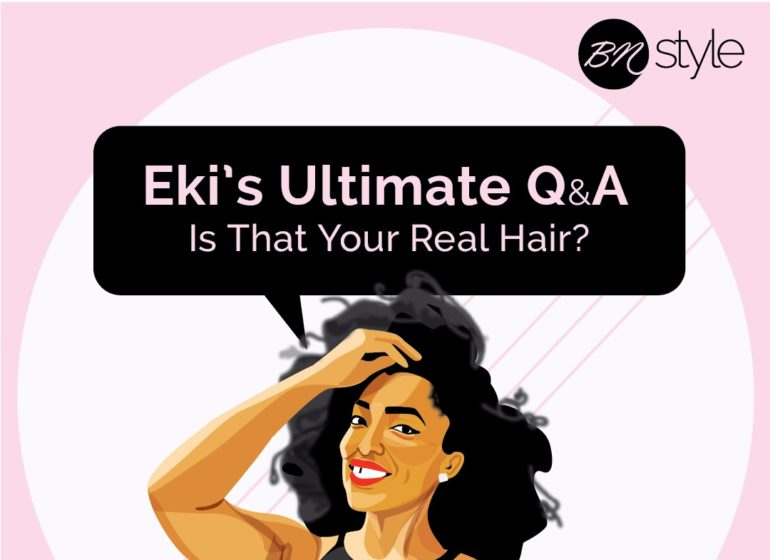Describe what the woman might talk about during a typical Q&A session. During a typical Q&A session, the woman might address common questions about natural hair, such as the best methods to transition from relaxed to natural hair and how to identify one's curl pattern. She could provide insights on avoiding breakage by detailing protective styling techniques like braids, twists, and buns. She might discuss the importance of a nighttime routine, like using satin scarves or pillowcases to reduce friction, and share DIY hair mask recipes that include ingredients like avocado, honey, and yogurt. Additionally, she could touch on the historical and cultural significance of natural hair, encouraging viewers to embrace their natural beauty with confidence.  If the woman in the image were a historical figure, what kind of impact might she have had? If the woman in the image were a historical figure, she might have been a powerful advocate for natural beauty and self-acceptance. She could have led movements or campaigns emphasizing the importance of embracing one's natural hair and challenging societal standards of beauty. Through public speeches, writings, and community outreach, she would inspire others to take pride in their unique features. Her impact could extend to influencing fashion and beauty industries to be more inclusive and representative of diverse hair textures and styles, leaving a legacy of empowerment and acceptance. Additionally, her work might have also contributed to the legislative sphere, helping to pass anti-discrimination laws protecting individuals based on their natural hair and appearance. Can you create a short fictional story inspired by the image? Amara had always been fascinated by her grandmother's tales of the mystical Hair Garden, a place where every plant and flower held secrets to unparalleled haircare. One day, determined to find this enchanted garden, she set out on an adventure. Guided by the whispers of the wind and the soft rustle of leaves, she discovered a hidden grove glowing with golden light. In the center stood a majestic tree with sparkling leaves and blooms of every color imaginable. As she approached, the tree's flowers began to whisper tips about nurturing hair. Amara learned the art of creating nourishing hair elixirs from the dewdrops of the garden's blossoms. When she returned home, she shared the garden's secrets with her community, helping everyone embrace and enhance their natural hair. Amara's Hair Garden Elixirs became legendary, and her story inspired generations to cherish their natural beauty. 